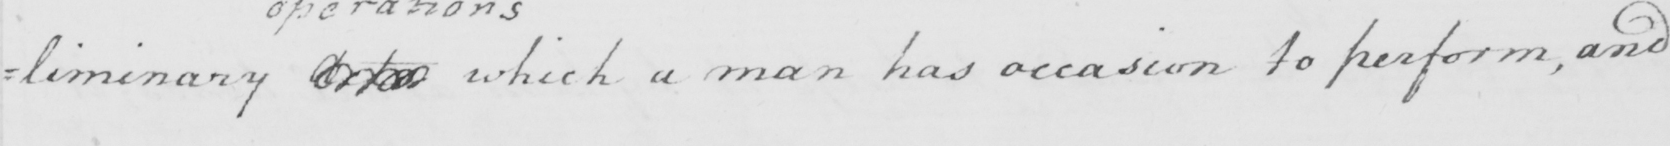Can you read and transcribe this handwriting? =liminary Acts which a man has occasion to perform, and 